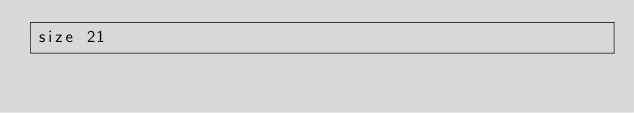Convert code to text. <code><loc_0><loc_0><loc_500><loc_500><_YAML_>size 21
</code> 